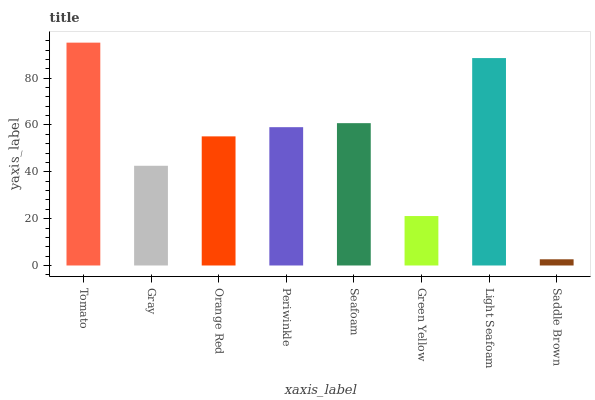Is Saddle Brown the minimum?
Answer yes or no. Yes. Is Tomato the maximum?
Answer yes or no. Yes. Is Gray the minimum?
Answer yes or no. No. Is Gray the maximum?
Answer yes or no. No. Is Tomato greater than Gray?
Answer yes or no. Yes. Is Gray less than Tomato?
Answer yes or no. Yes. Is Gray greater than Tomato?
Answer yes or no. No. Is Tomato less than Gray?
Answer yes or no. No. Is Periwinkle the high median?
Answer yes or no. Yes. Is Orange Red the low median?
Answer yes or no. Yes. Is Saddle Brown the high median?
Answer yes or no. No. Is Green Yellow the low median?
Answer yes or no. No. 